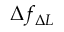<formula> <loc_0><loc_0><loc_500><loc_500>\Delta f _ { \Delta L }</formula> 